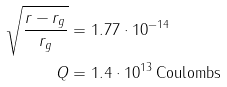Convert formula to latex. <formula><loc_0><loc_0><loc_500><loc_500>\sqrt { \frac { r - r _ { g } } { r _ { g } } } & = 1 . 7 7 \cdot 1 0 ^ { - 1 4 } \\ Q & = 1 . 4 \cdot 1 0 ^ { 1 3 } \, \text {Coulombs}</formula> 